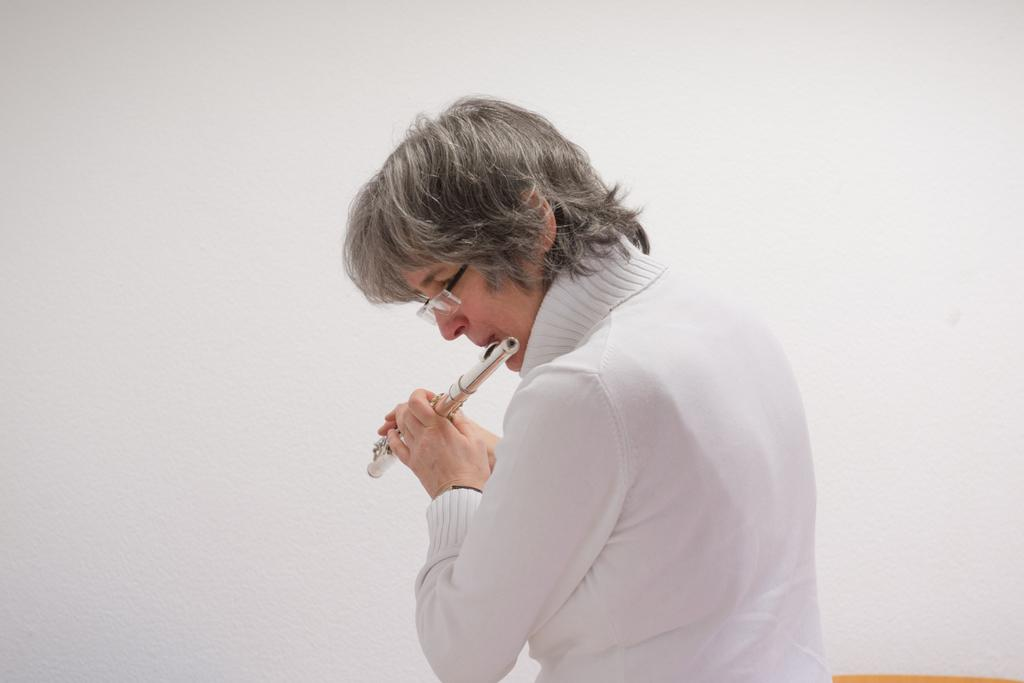Who is the main subject in the image? There is a woman in the image. What is the woman wearing? The woman is wearing a white dress. What is the woman doing in the image? The woman is playing a musical instrument. Can you describe any accessories the woman is wearing? The woman is wearing glasses (specs). What type of lunch is the woman eating in the image? There is no lunch present in the image; the woman is playing a musical instrument. Is the woman a farmer in the image? There is no indication in the image that the woman is a farmer. 